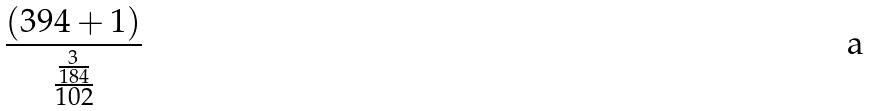<formula> <loc_0><loc_0><loc_500><loc_500>\frac { ( 3 9 4 + 1 ) } { \frac { \frac { 3 } { 1 8 4 } } { 1 0 2 } }</formula> 